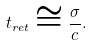Convert formula to latex. <formula><loc_0><loc_0><loc_500><loc_500>t _ { r e t } \cong \frac { \sigma } { c } .</formula> 